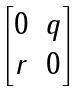<formula> <loc_0><loc_0><loc_500><loc_500>\begin{bmatrix} 0 & q \\ r & 0 \end{bmatrix}</formula> 